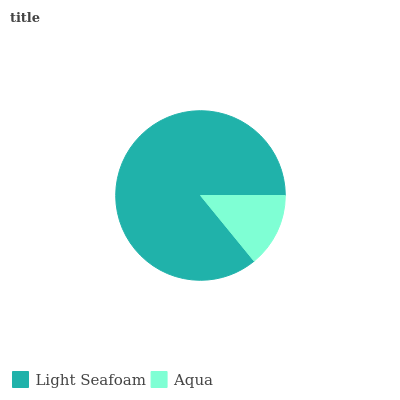Is Aqua the minimum?
Answer yes or no. Yes. Is Light Seafoam the maximum?
Answer yes or no. Yes. Is Aqua the maximum?
Answer yes or no. No. Is Light Seafoam greater than Aqua?
Answer yes or no. Yes. Is Aqua less than Light Seafoam?
Answer yes or no. Yes. Is Aqua greater than Light Seafoam?
Answer yes or no. No. Is Light Seafoam less than Aqua?
Answer yes or no. No. Is Light Seafoam the high median?
Answer yes or no. Yes. Is Aqua the low median?
Answer yes or no. Yes. Is Aqua the high median?
Answer yes or no. No. Is Light Seafoam the low median?
Answer yes or no. No. 